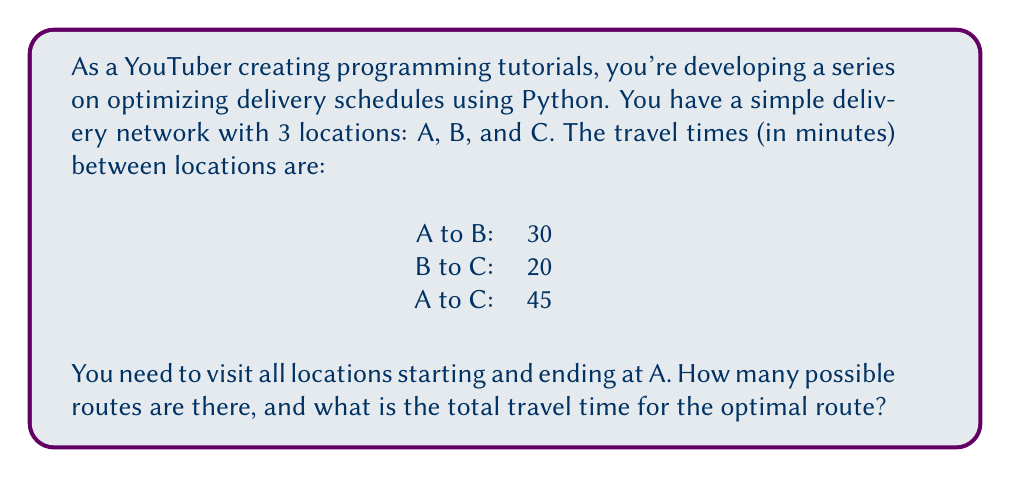Help me with this question. Let's approach this step-by-step:

1. First, let's identify all possible routes:
   - A → B → C → A
   - A → C → B → A

2. There are 2 possible routes in total.

3. Now, let's calculate the travel time for each route:

   Route 1: A → B → C → A
   $$ T_1 = T_{AB} + T_{BC} + T_{CA} = 30 + 20 + 45 = 95 \text{ minutes} $$

   Route 2: A → C → B → A
   $$ T_2 = T_{AC} + T_{CB} + T_{BA} = 45 + 20 + 30 = 95 \text{ minutes} $$

4. Comparing the two routes:
   Both routes have the same total travel time of 95 minutes.

5. Therefore, the optimal route can be either A → B → C → A or A → C → B → A, as they both result in the minimum travel time of 95 minutes.

This problem demonstrates the concept of finding the optimal solution in a simple traveling salesman problem, which is a common application in delivery route optimization.
Answer: There are 2 possible routes, and the optimal route has a total travel time of 95 minutes. 